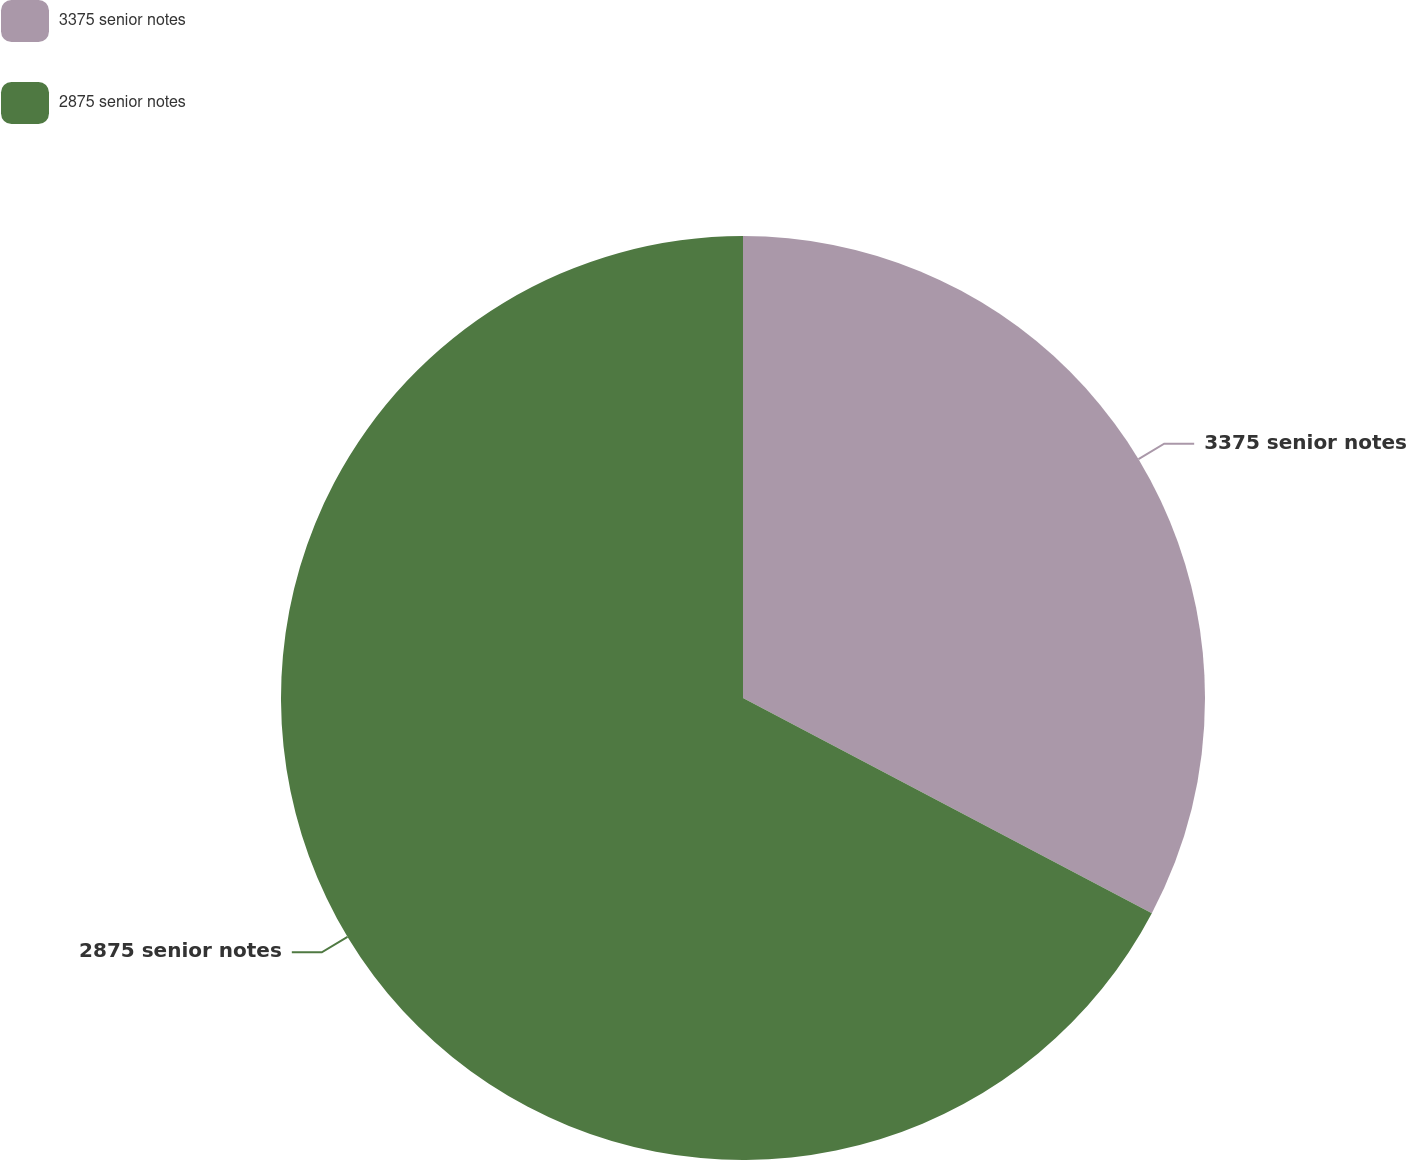Convert chart. <chart><loc_0><loc_0><loc_500><loc_500><pie_chart><fcel>3375 senior notes<fcel>2875 senior notes<nl><fcel>32.71%<fcel>67.29%<nl></chart> 